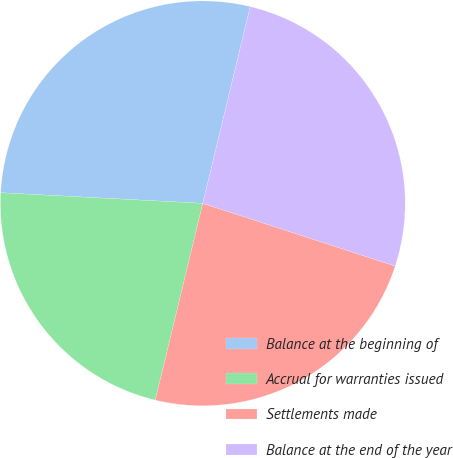<chart> <loc_0><loc_0><loc_500><loc_500><pie_chart><fcel>Balance at the beginning of<fcel>Accrual for warranties issued<fcel>Settlements made<fcel>Balance at the end of the year<nl><fcel>27.93%<fcel>22.07%<fcel>23.75%<fcel>26.25%<nl></chart> 